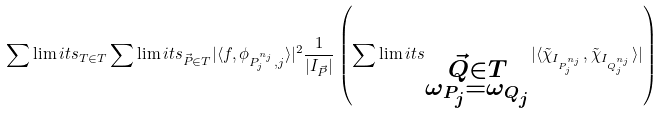Convert formula to latex. <formula><loc_0><loc_0><loc_500><loc_500>\sum \lim i t s _ { T \in T } \sum \lim i t s _ { \vec { P } \in T } | \langle f , \phi _ { P _ { j } ^ { n _ { j } } , j } \rangle | ^ { 2 } \frac { 1 } { | I _ { \vec { P } } | } \left ( \sum \lim i t s _ { \substack { \vec { Q } \in T \\ \omega _ { P _ { j } } = \omega _ { Q _ { j } } } } | \langle \tilde { \chi } _ { I _ { P _ { j } ^ { n _ { j } } } } , \tilde { \chi } _ { I _ { Q _ { j } ^ { n _ { j } } } } \rangle | \right )</formula> 